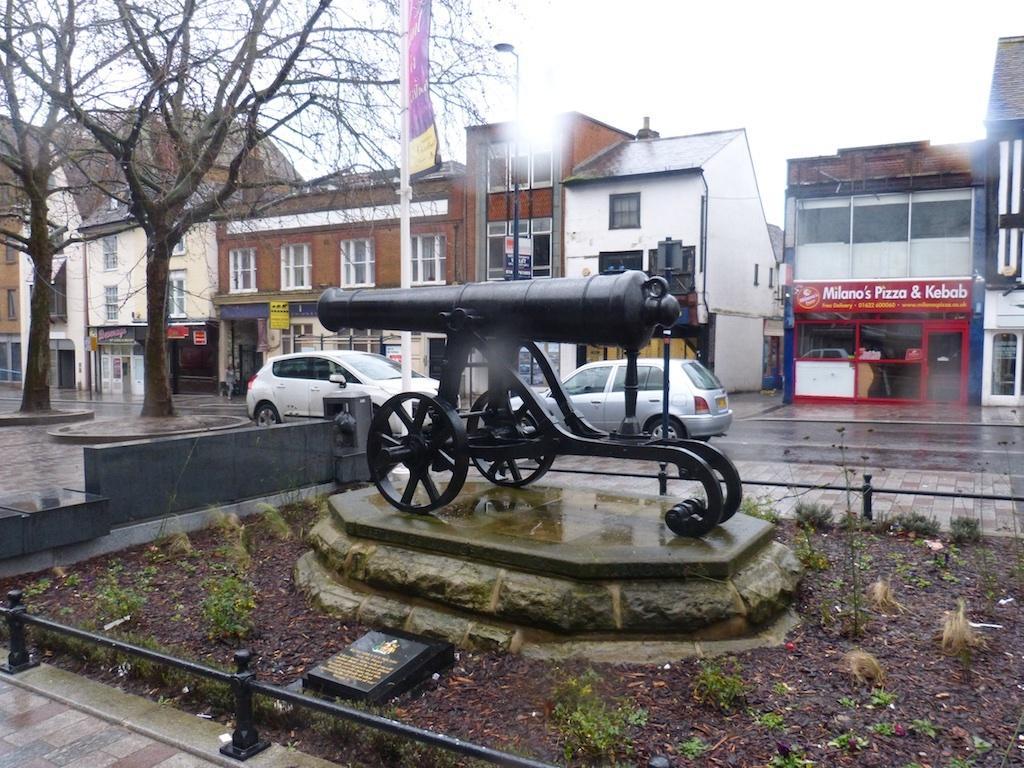Please provide a concise description of this image. In the image there is a sculpture of a weapon kept on a stone and around that sculpture there are trees, vehicles and buildings. 